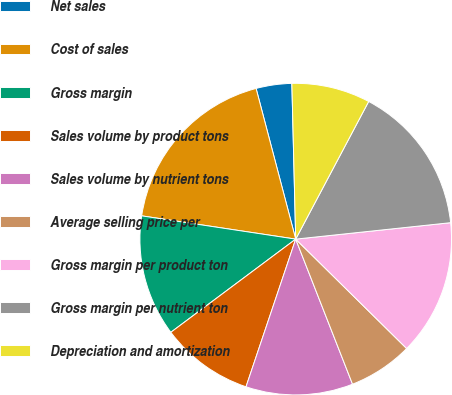Convert chart. <chart><loc_0><loc_0><loc_500><loc_500><pie_chart><fcel>Net sales<fcel>Cost of sales<fcel>Gross margin<fcel>Sales volume by product tons<fcel>Sales volume by nutrient tons<fcel>Average selling price per<fcel>Gross margin per product ton<fcel>Gross margin per nutrient ton<fcel>Depreciation and amortization<nl><fcel>3.7%<fcel>18.52%<fcel>12.59%<fcel>9.63%<fcel>11.11%<fcel>6.67%<fcel>14.07%<fcel>15.56%<fcel>8.15%<nl></chart> 